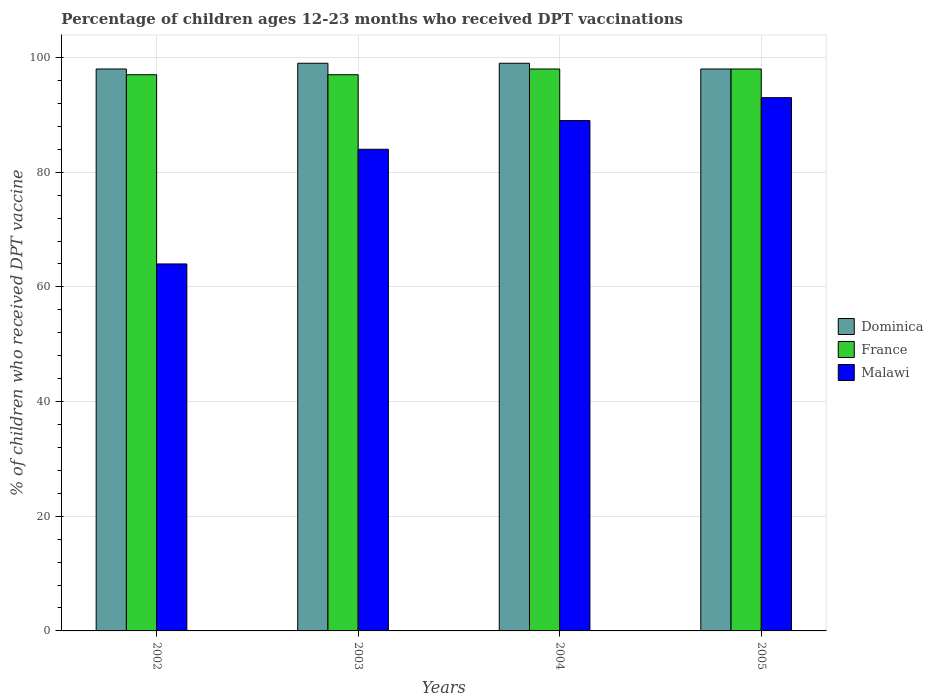How many different coloured bars are there?
Your answer should be compact. 3. How many bars are there on the 2nd tick from the left?
Your answer should be compact. 3. In how many cases, is the number of bars for a given year not equal to the number of legend labels?
Offer a terse response. 0. What is the percentage of children who received DPT vaccination in Malawi in 2005?
Give a very brief answer. 93. Across all years, what is the maximum percentage of children who received DPT vaccination in France?
Offer a very short reply. 98. Across all years, what is the minimum percentage of children who received DPT vaccination in Dominica?
Give a very brief answer. 98. In which year was the percentage of children who received DPT vaccination in Dominica minimum?
Offer a very short reply. 2002. What is the total percentage of children who received DPT vaccination in Malawi in the graph?
Keep it short and to the point. 330. What is the difference between the percentage of children who received DPT vaccination in Dominica in 2002 and that in 2003?
Your answer should be very brief. -1. What is the difference between the percentage of children who received DPT vaccination in France in 2005 and the percentage of children who received DPT vaccination in Dominica in 2002?
Offer a terse response. 0. What is the average percentage of children who received DPT vaccination in Malawi per year?
Offer a very short reply. 82.5. In the year 2002, what is the difference between the percentage of children who received DPT vaccination in Dominica and percentage of children who received DPT vaccination in Malawi?
Offer a terse response. 34. What is the ratio of the percentage of children who received DPT vaccination in Malawi in 2004 to that in 2005?
Ensure brevity in your answer.  0.96. What is the difference between the highest and the second highest percentage of children who received DPT vaccination in Dominica?
Ensure brevity in your answer.  0. What is the difference between the highest and the lowest percentage of children who received DPT vaccination in Dominica?
Offer a very short reply. 1. Is the sum of the percentage of children who received DPT vaccination in Dominica in 2002 and 2004 greater than the maximum percentage of children who received DPT vaccination in Malawi across all years?
Your answer should be very brief. Yes. What does the 1st bar from the left in 2005 represents?
Ensure brevity in your answer.  Dominica. What does the 2nd bar from the right in 2003 represents?
Ensure brevity in your answer.  France. What is the difference between two consecutive major ticks on the Y-axis?
Provide a succinct answer. 20. Are the values on the major ticks of Y-axis written in scientific E-notation?
Offer a terse response. No. Does the graph contain any zero values?
Keep it short and to the point. No. Does the graph contain grids?
Offer a very short reply. Yes. How many legend labels are there?
Your response must be concise. 3. What is the title of the graph?
Give a very brief answer. Percentage of children ages 12-23 months who received DPT vaccinations. Does "Chad" appear as one of the legend labels in the graph?
Your response must be concise. No. What is the label or title of the Y-axis?
Provide a short and direct response. % of children who received DPT vaccine. What is the % of children who received DPT vaccine in France in 2002?
Keep it short and to the point. 97. What is the % of children who received DPT vaccine of Malawi in 2002?
Your response must be concise. 64. What is the % of children who received DPT vaccine of Dominica in 2003?
Give a very brief answer. 99. What is the % of children who received DPT vaccine in France in 2003?
Offer a very short reply. 97. What is the % of children who received DPT vaccine in Malawi in 2003?
Provide a succinct answer. 84. What is the % of children who received DPT vaccine of Dominica in 2004?
Ensure brevity in your answer.  99. What is the % of children who received DPT vaccine in France in 2004?
Your answer should be very brief. 98. What is the % of children who received DPT vaccine of Malawi in 2004?
Your response must be concise. 89. What is the % of children who received DPT vaccine in France in 2005?
Keep it short and to the point. 98. What is the % of children who received DPT vaccine of Malawi in 2005?
Offer a terse response. 93. Across all years, what is the maximum % of children who received DPT vaccine of Malawi?
Your answer should be very brief. 93. Across all years, what is the minimum % of children who received DPT vaccine of France?
Keep it short and to the point. 97. Across all years, what is the minimum % of children who received DPT vaccine of Malawi?
Give a very brief answer. 64. What is the total % of children who received DPT vaccine in Dominica in the graph?
Ensure brevity in your answer.  394. What is the total % of children who received DPT vaccine of France in the graph?
Your answer should be compact. 390. What is the total % of children who received DPT vaccine in Malawi in the graph?
Your response must be concise. 330. What is the difference between the % of children who received DPT vaccine in France in 2002 and that in 2003?
Provide a succinct answer. 0. What is the difference between the % of children who received DPT vaccine in Dominica in 2002 and that in 2004?
Give a very brief answer. -1. What is the difference between the % of children who received DPT vaccine of France in 2002 and that in 2005?
Your answer should be compact. -1. What is the difference between the % of children who received DPT vaccine in Malawi in 2002 and that in 2005?
Give a very brief answer. -29. What is the difference between the % of children who received DPT vaccine in France in 2003 and that in 2004?
Your answer should be compact. -1. What is the difference between the % of children who received DPT vaccine in Dominica in 2003 and that in 2005?
Offer a terse response. 1. What is the difference between the % of children who received DPT vaccine in France in 2003 and that in 2005?
Your answer should be compact. -1. What is the difference between the % of children who received DPT vaccine in Malawi in 2004 and that in 2005?
Provide a succinct answer. -4. What is the difference between the % of children who received DPT vaccine in Dominica in 2002 and the % of children who received DPT vaccine in Malawi in 2003?
Your answer should be very brief. 14. What is the difference between the % of children who received DPT vaccine in France in 2002 and the % of children who received DPT vaccine in Malawi in 2003?
Provide a short and direct response. 13. What is the difference between the % of children who received DPT vaccine in Dominica in 2003 and the % of children who received DPT vaccine in Malawi in 2004?
Keep it short and to the point. 10. What is the difference between the % of children who received DPT vaccine in Dominica in 2003 and the % of children who received DPT vaccine in France in 2005?
Give a very brief answer. 1. What is the difference between the % of children who received DPT vaccine of Dominica in 2003 and the % of children who received DPT vaccine of Malawi in 2005?
Your answer should be very brief. 6. What is the difference between the % of children who received DPT vaccine in Dominica in 2004 and the % of children who received DPT vaccine in France in 2005?
Your answer should be very brief. 1. What is the difference between the % of children who received DPT vaccine of Dominica in 2004 and the % of children who received DPT vaccine of Malawi in 2005?
Ensure brevity in your answer.  6. What is the difference between the % of children who received DPT vaccine in France in 2004 and the % of children who received DPT vaccine in Malawi in 2005?
Ensure brevity in your answer.  5. What is the average % of children who received DPT vaccine in Dominica per year?
Ensure brevity in your answer.  98.5. What is the average % of children who received DPT vaccine of France per year?
Your response must be concise. 97.5. What is the average % of children who received DPT vaccine in Malawi per year?
Ensure brevity in your answer.  82.5. In the year 2002, what is the difference between the % of children who received DPT vaccine in Dominica and % of children who received DPT vaccine in France?
Keep it short and to the point. 1. In the year 2002, what is the difference between the % of children who received DPT vaccine in Dominica and % of children who received DPT vaccine in Malawi?
Offer a very short reply. 34. In the year 2002, what is the difference between the % of children who received DPT vaccine of France and % of children who received DPT vaccine of Malawi?
Provide a short and direct response. 33. In the year 2003, what is the difference between the % of children who received DPT vaccine of Dominica and % of children who received DPT vaccine of France?
Provide a short and direct response. 2. In the year 2003, what is the difference between the % of children who received DPT vaccine of Dominica and % of children who received DPT vaccine of Malawi?
Give a very brief answer. 15. In the year 2003, what is the difference between the % of children who received DPT vaccine of France and % of children who received DPT vaccine of Malawi?
Provide a short and direct response. 13. In the year 2004, what is the difference between the % of children who received DPT vaccine in Dominica and % of children who received DPT vaccine in Malawi?
Your response must be concise. 10. In the year 2004, what is the difference between the % of children who received DPT vaccine in France and % of children who received DPT vaccine in Malawi?
Offer a very short reply. 9. What is the ratio of the % of children who received DPT vaccine of Malawi in 2002 to that in 2003?
Your response must be concise. 0.76. What is the ratio of the % of children who received DPT vaccine of Dominica in 2002 to that in 2004?
Give a very brief answer. 0.99. What is the ratio of the % of children who received DPT vaccine of France in 2002 to that in 2004?
Provide a succinct answer. 0.99. What is the ratio of the % of children who received DPT vaccine in Malawi in 2002 to that in 2004?
Provide a short and direct response. 0.72. What is the ratio of the % of children who received DPT vaccine in Dominica in 2002 to that in 2005?
Offer a terse response. 1. What is the ratio of the % of children who received DPT vaccine of Malawi in 2002 to that in 2005?
Your answer should be compact. 0.69. What is the ratio of the % of children who received DPT vaccine in France in 2003 to that in 2004?
Ensure brevity in your answer.  0.99. What is the ratio of the % of children who received DPT vaccine in Malawi in 2003 to that in 2004?
Provide a succinct answer. 0.94. What is the ratio of the % of children who received DPT vaccine in Dominica in 2003 to that in 2005?
Make the answer very short. 1.01. What is the ratio of the % of children who received DPT vaccine of France in 2003 to that in 2005?
Provide a short and direct response. 0.99. What is the ratio of the % of children who received DPT vaccine in Malawi in 2003 to that in 2005?
Provide a short and direct response. 0.9. What is the ratio of the % of children who received DPT vaccine in Dominica in 2004 to that in 2005?
Provide a short and direct response. 1.01. What is the ratio of the % of children who received DPT vaccine of France in 2004 to that in 2005?
Give a very brief answer. 1. What is the ratio of the % of children who received DPT vaccine of Malawi in 2004 to that in 2005?
Keep it short and to the point. 0.96. What is the difference between the highest and the second highest % of children who received DPT vaccine of Dominica?
Ensure brevity in your answer.  0. What is the difference between the highest and the lowest % of children who received DPT vaccine in Malawi?
Provide a succinct answer. 29. 